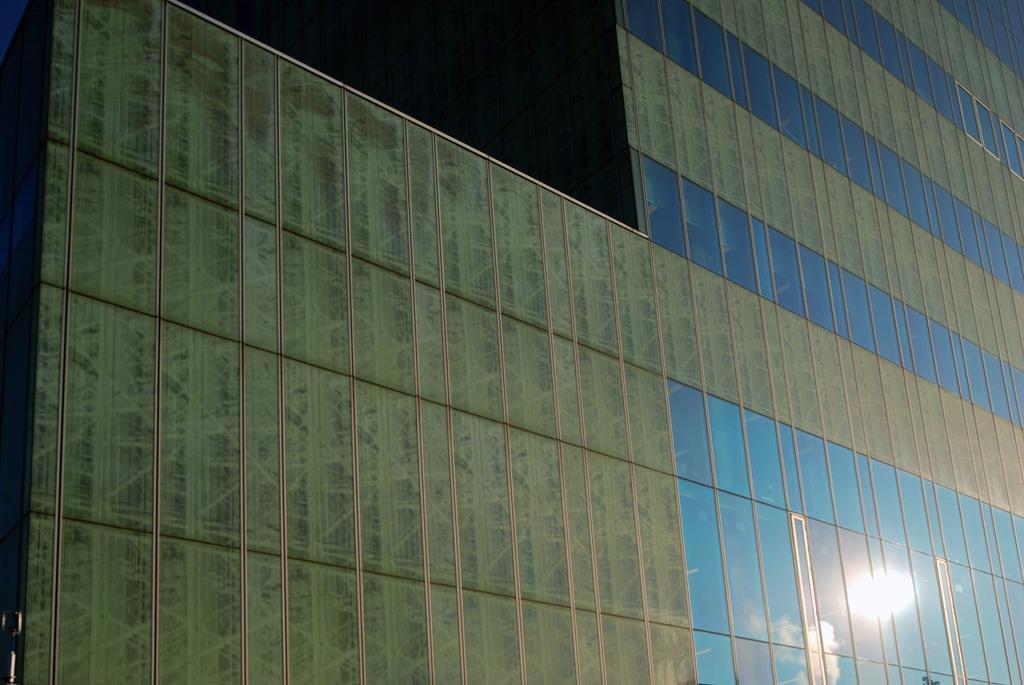Can you describe this image briefly? These are the glass walls of a building. 